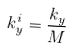Convert formula to latex. <formula><loc_0><loc_0><loc_500><loc_500>k _ { y } ^ { i } = \frac { k _ { y } } { M }</formula> 